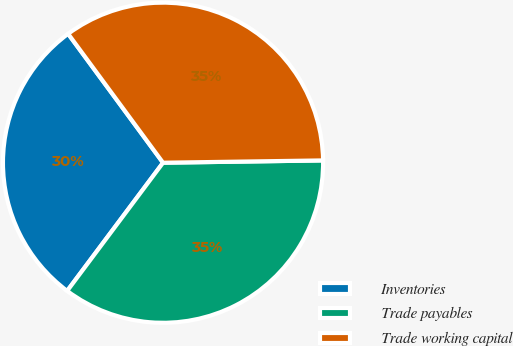<chart> <loc_0><loc_0><loc_500><loc_500><pie_chart><fcel>Inventories<fcel>Trade payables<fcel>Trade working capital<nl><fcel>29.68%<fcel>35.45%<fcel>34.87%<nl></chart> 